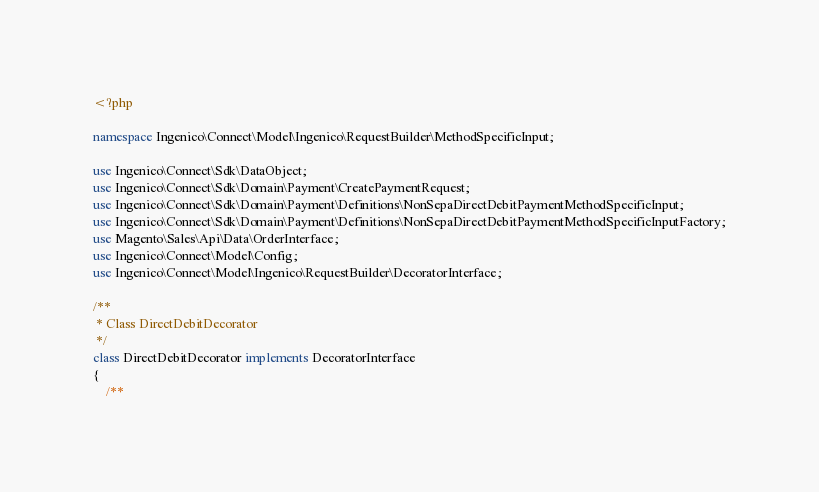<code> <loc_0><loc_0><loc_500><loc_500><_PHP_><?php

namespace Ingenico\Connect\Model\Ingenico\RequestBuilder\MethodSpecificInput;

use Ingenico\Connect\Sdk\DataObject;
use Ingenico\Connect\Sdk\Domain\Payment\CreatePaymentRequest;
use Ingenico\Connect\Sdk\Domain\Payment\Definitions\NonSepaDirectDebitPaymentMethodSpecificInput;
use Ingenico\Connect\Sdk\Domain\Payment\Definitions\NonSepaDirectDebitPaymentMethodSpecificInputFactory;
use Magento\Sales\Api\Data\OrderInterface;
use Ingenico\Connect\Model\Config;
use Ingenico\Connect\Model\Ingenico\RequestBuilder\DecoratorInterface;

/**
 * Class DirectDebitDecorator
 */
class DirectDebitDecorator implements DecoratorInterface
{
    /**</code> 